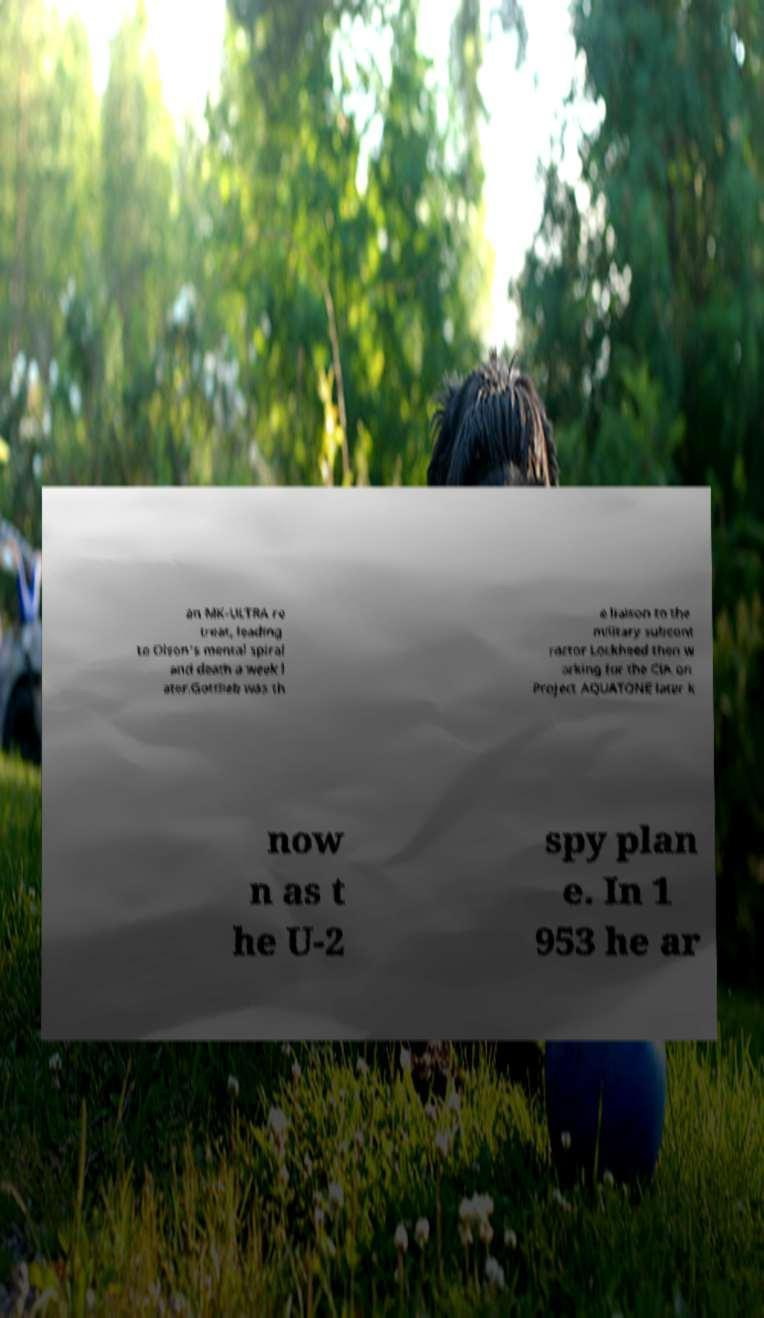Can you accurately transcribe the text from the provided image for me? an MK-ULTRA re treat, leading to Olson's mental spiral and death a week l ater.Gottlieb was th e liaison to the military subcont ractor Lockheed then w orking for the CIA on Project AQUATONE later k now n as t he U-2 spy plan e. In 1 953 he ar 